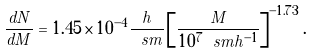<formula> <loc_0><loc_0><loc_500><loc_500>\frac { d N } { d M } = 1 . 4 5 \times 1 0 ^ { - 4 } \frac { h } { \ s m } \left [ \frac { M } { 1 0 ^ { 7 } \ s m h ^ { - 1 } } \right ] ^ { - 1 . 7 3 } .</formula> 